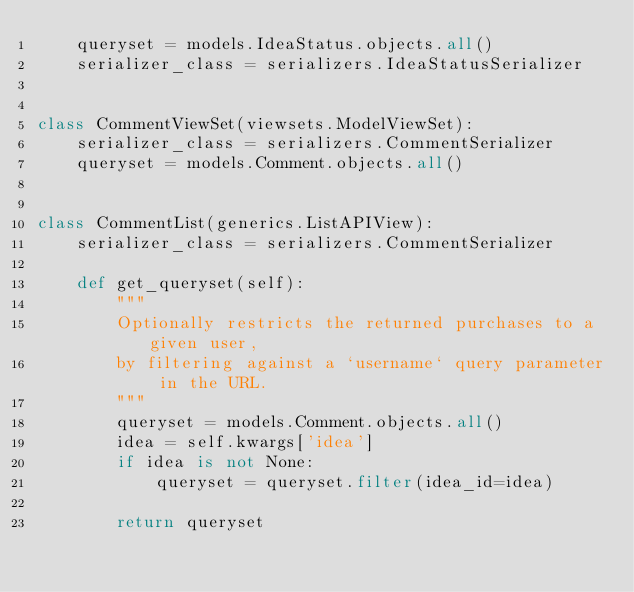<code> <loc_0><loc_0><loc_500><loc_500><_Python_>    queryset = models.IdeaStatus.objects.all()
    serializer_class = serializers.IdeaStatusSerializer


class CommentViewSet(viewsets.ModelViewSet):
    serializer_class = serializers.CommentSerializer
    queryset = models.Comment.objects.all()


class CommentList(generics.ListAPIView):
    serializer_class = serializers.CommentSerializer

    def get_queryset(self):
        """
        Optionally restricts the returned purchases to a given user,
        by filtering against a `username` query parameter in the URL.
        """
        queryset = models.Comment.objects.all()
        idea = self.kwargs['idea']
        if idea is not None:
            queryset = queryset.filter(idea_id=idea)

        return queryset
</code> 